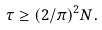Convert formula to latex. <formula><loc_0><loc_0><loc_500><loc_500>\tau \geq ( 2 / \pi ) ^ { 2 } N .</formula> 